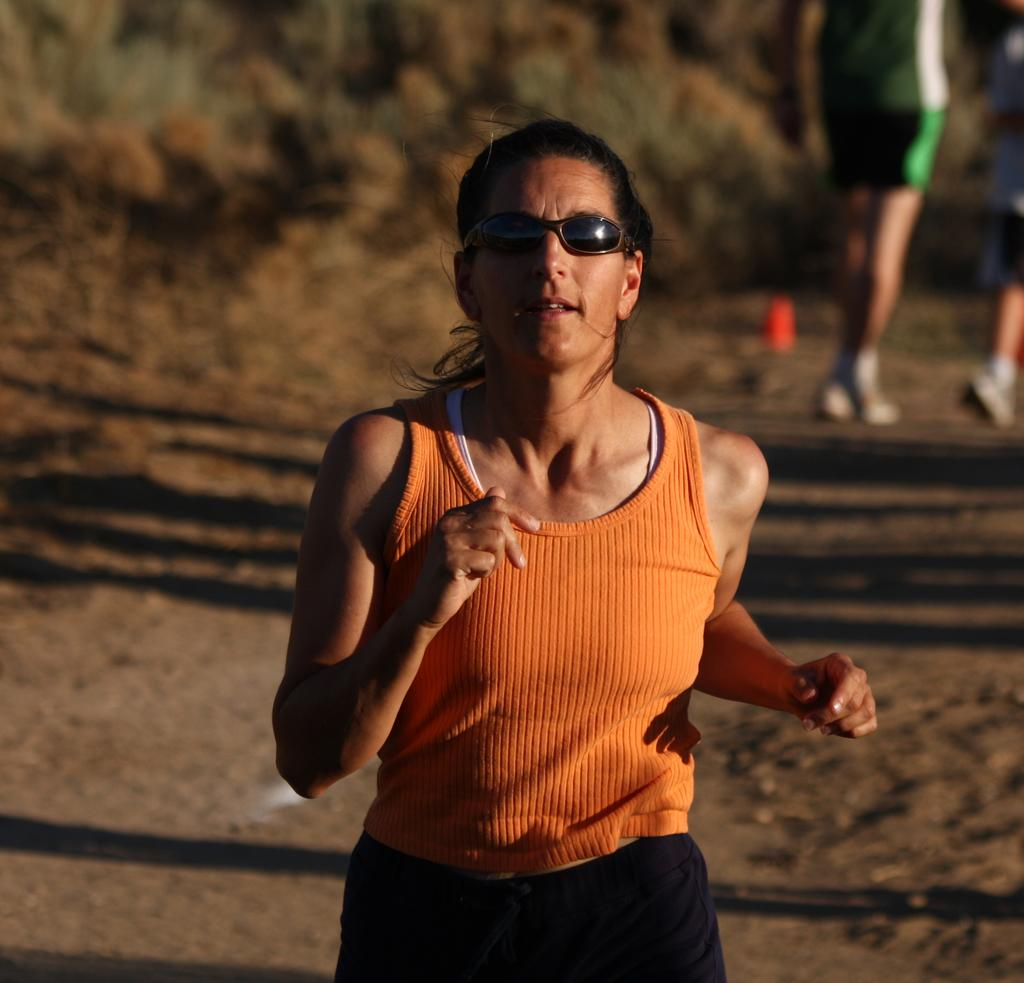What is the person in the image wearing on their upper body? The person in the image is wearing an orange top. What accessory is the person wearing on their face? The person is wearing spectacles. What are the other people in the image doing? The other people in the image are on the floor. What type of son can be heard in the background of the image? There is no son or sound present in the image, as it is a still photograph. 